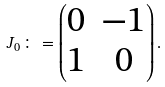Convert formula to latex. <formula><loc_0><loc_0><loc_500><loc_500>J _ { 0 } \colon = \begin{pmatrix} 0 & - 1 \\ 1 & 0 \end{pmatrix} .</formula> 